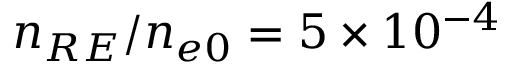<formula> <loc_0><loc_0><loc_500><loc_500>n _ { R E } / n _ { e 0 } = 5 \times 1 0 ^ { - 4 }</formula> 